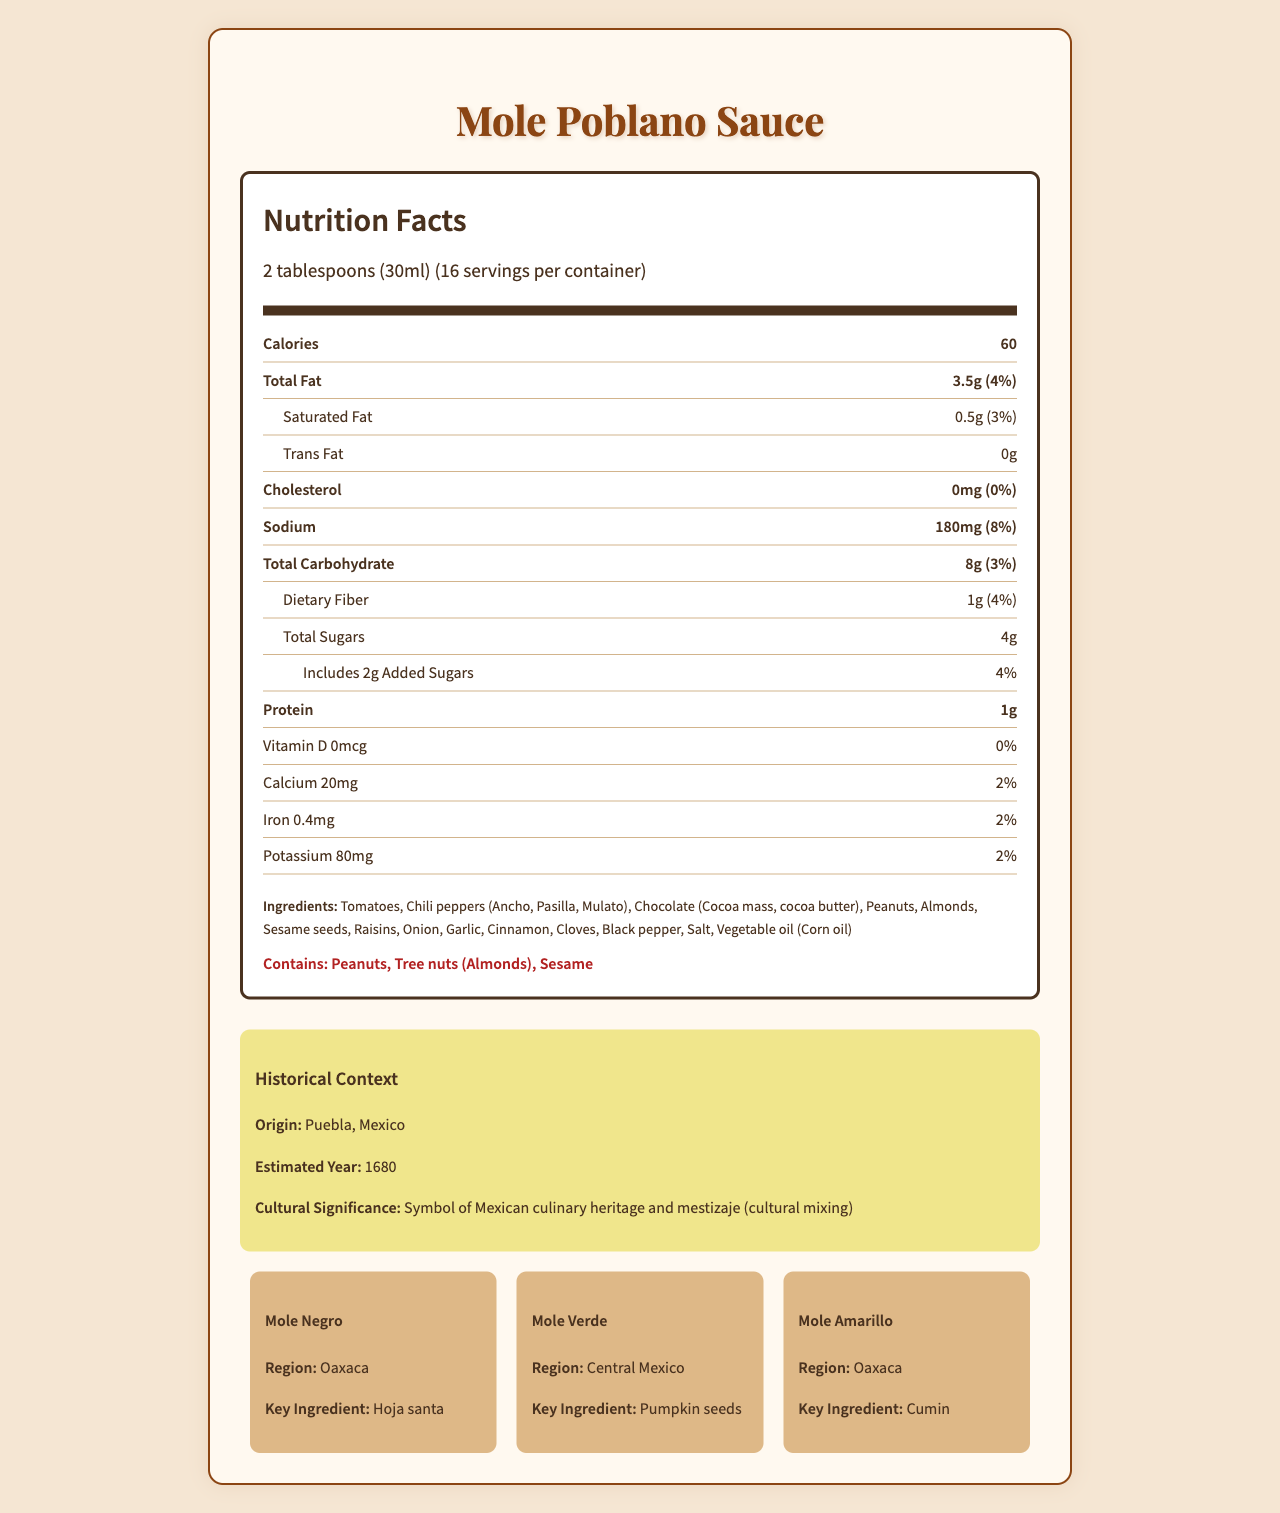what is the serving size? The serving size is listed in the "Nutrition Facts" section under the serving information.
Answer: 2 tablespoons (30ml) how many calories are there per serving? The number of calories per serving is provided directly under the bold "Calories" label.
Answer: 60 which type of fat has the lowest amount per serving? A. Total Fat B. Saturated Fat C. Trans Fat The Trans Fat amount per serving is listed as 0g.
Answer: C is there any cholesterol in a serving of mole sauce? The "Cholesterol" section states that there is 0mg of cholesterol per serving.
Answer: No how much iron is in each serving? The document states that each serving contains 0.4 mg of iron.
Answer: 0.4 mg what are the key ingredients in Mole Poblano Sauce? The ingredients list provides a detailed breakdown of what is included in the Mole Poblano Sauce.
Answer: Tomatoes, Chili peppers (Ancho, Pasilla, Mulato), Chocolate, Peanuts, Almonds, Sesame seeds, Raisins, Onion, Garlic, Cinnamon, Cloves, Black pepper, Salt, Vegetable oil (Corn oil) how much added sugar is in a serving of mole sauce? The "Includes Added Sugars" section states that a serving contains 2g of added sugars.
Answer: 2 g What is the most notable allergenic ingredient? The allergen section lists peanuts first among the allergens in the sauce.
Answer: Peanuts what is the origin of Mole Poblano Sauce? The historical context states that the origin of Mole Poblano Sauce is Puebla, Mexico.
Answer: Puebla, Mexico how many servings are in the container? The document states that there are 16 servings per container.
Answer: 16 which cultural factor is associated with Mole Poblano Sauce? A. Economic trade B. Mestizaje C. Religious ceremonies The cultural significance part of the historical context notes that Mole Poblano is a symbol of Mexican culinary heritage and mestizaje.
Answer: B did Mole Poblano Sauce originate before or after 1700? The historical context states that the estimated year of origin is 1680.
Answer: Before how many grams of total carbohydrate does each serving contain? The "Total Carbohydrate" section indicates that each serving has 8g of total carbohydrate.
Answer: 8 g which historical period introduced ingredients like almonds and sesame seeds to mole sauce? The nutritional trends section mentions that the colonial period saw the incorporation of Old World ingredients like almonds and sesame seeds.
Answer: Colonial what is the main idea of the document? The document includes a detailed breakdown of the sauce's nutritional content, ingredients, allergens, origin, historical importance, and regional variations.
Answer: The document provides a comprehensive overview of the nutrition facts, ingredients, allergens, historical context, and regional variations of Mole Poblano Sauce, highlighting its cultural significance and nutritional profile. explain the nutritional trends in mole sauce from precolonial to modern times? The document's nutritional trends section provides a timeline of how mole sauce ingredients evolved over time.
Answer: Precolonial mole sauces were based on indigenous ingredients, such as chili peppers, tomatoes, and cacao. During the colonial period, almonds, sesame seeds, and cinnamon were incorporated. Modern versions of mole adjust for health concerns by reducing sugar and sodium. how much potassium does each serving provide? The document specifies that each serving contains 80mg of potassium.
Answer: 80 mg which regional variation of mole sauce uses pumpkin seeds as a key ingredient? A. Mole Negro B. Mole Verde C. Mole Amarillo The document mentions that Mole Verde from Central Mexico uses pumpkin seeds as a key ingredient.
Answer: B What is the estimated year of origin for Mole Poblano Sauce? The historical context lists 1680 as the estimated year of origin.
Answer: 1680 how much vitamin D is in each serving? The "Vitamin D" section lists 0mcg per serving.
Answer: 0 mcg when was Mole Poblano Sauce first developed? The document does not provide enough information to determine the exact year or circumstances surrounding its first development.
Answer: Not enough information how many grams of dietary fiber are in one serving of mole sauce? The "Dietary Fiber" section indicates that each serving contains 1g of dietary fiber.
Answer: 1 g 